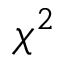<formula> <loc_0><loc_0><loc_500><loc_500>\chi ^ { 2 }</formula> 